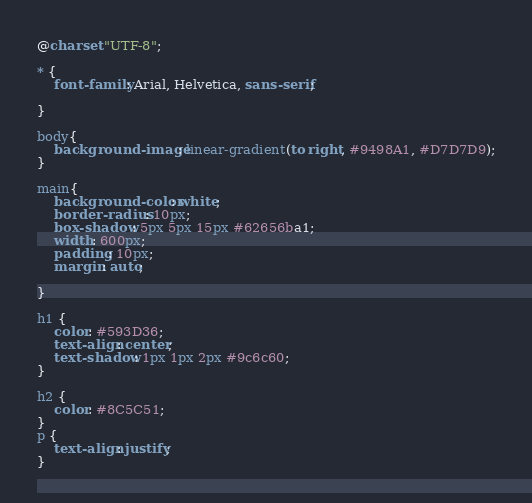<code> <loc_0><loc_0><loc_500><loc_500><_CSS_>@charset "UTF-8";

* {
    font-family: Arial, Helvetica, sans-serif;
    
}

body{
    background-image: linear-gradient(to right, #9498A1, #D7D7D9);
}

main{
    background-color: white;
    border-radius: 10px;
    box-shadow: 5px 5px 15px #62656ba1;
    width: 600px;
    padding: 10px;
    margin: auto;
    
}

h1 {
    color: #593D36;
    text-align: center;
    text-shadow: 1px 1px 2px #9c6c60;
}

h2 {
    color: #8C5C51;
}
p {
    text-align: justify;
}

</code> 